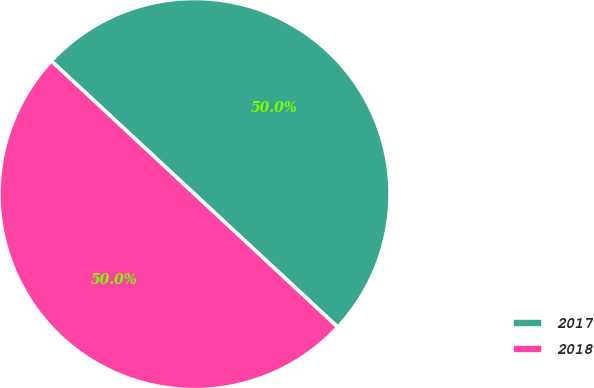<chart> <loc_0><loc_0><loc_500><loc_500><pie_chart><fcel>2017<fcel>2018<nl><fcel>50.0%<fcel>50.0%<nl></chart> 